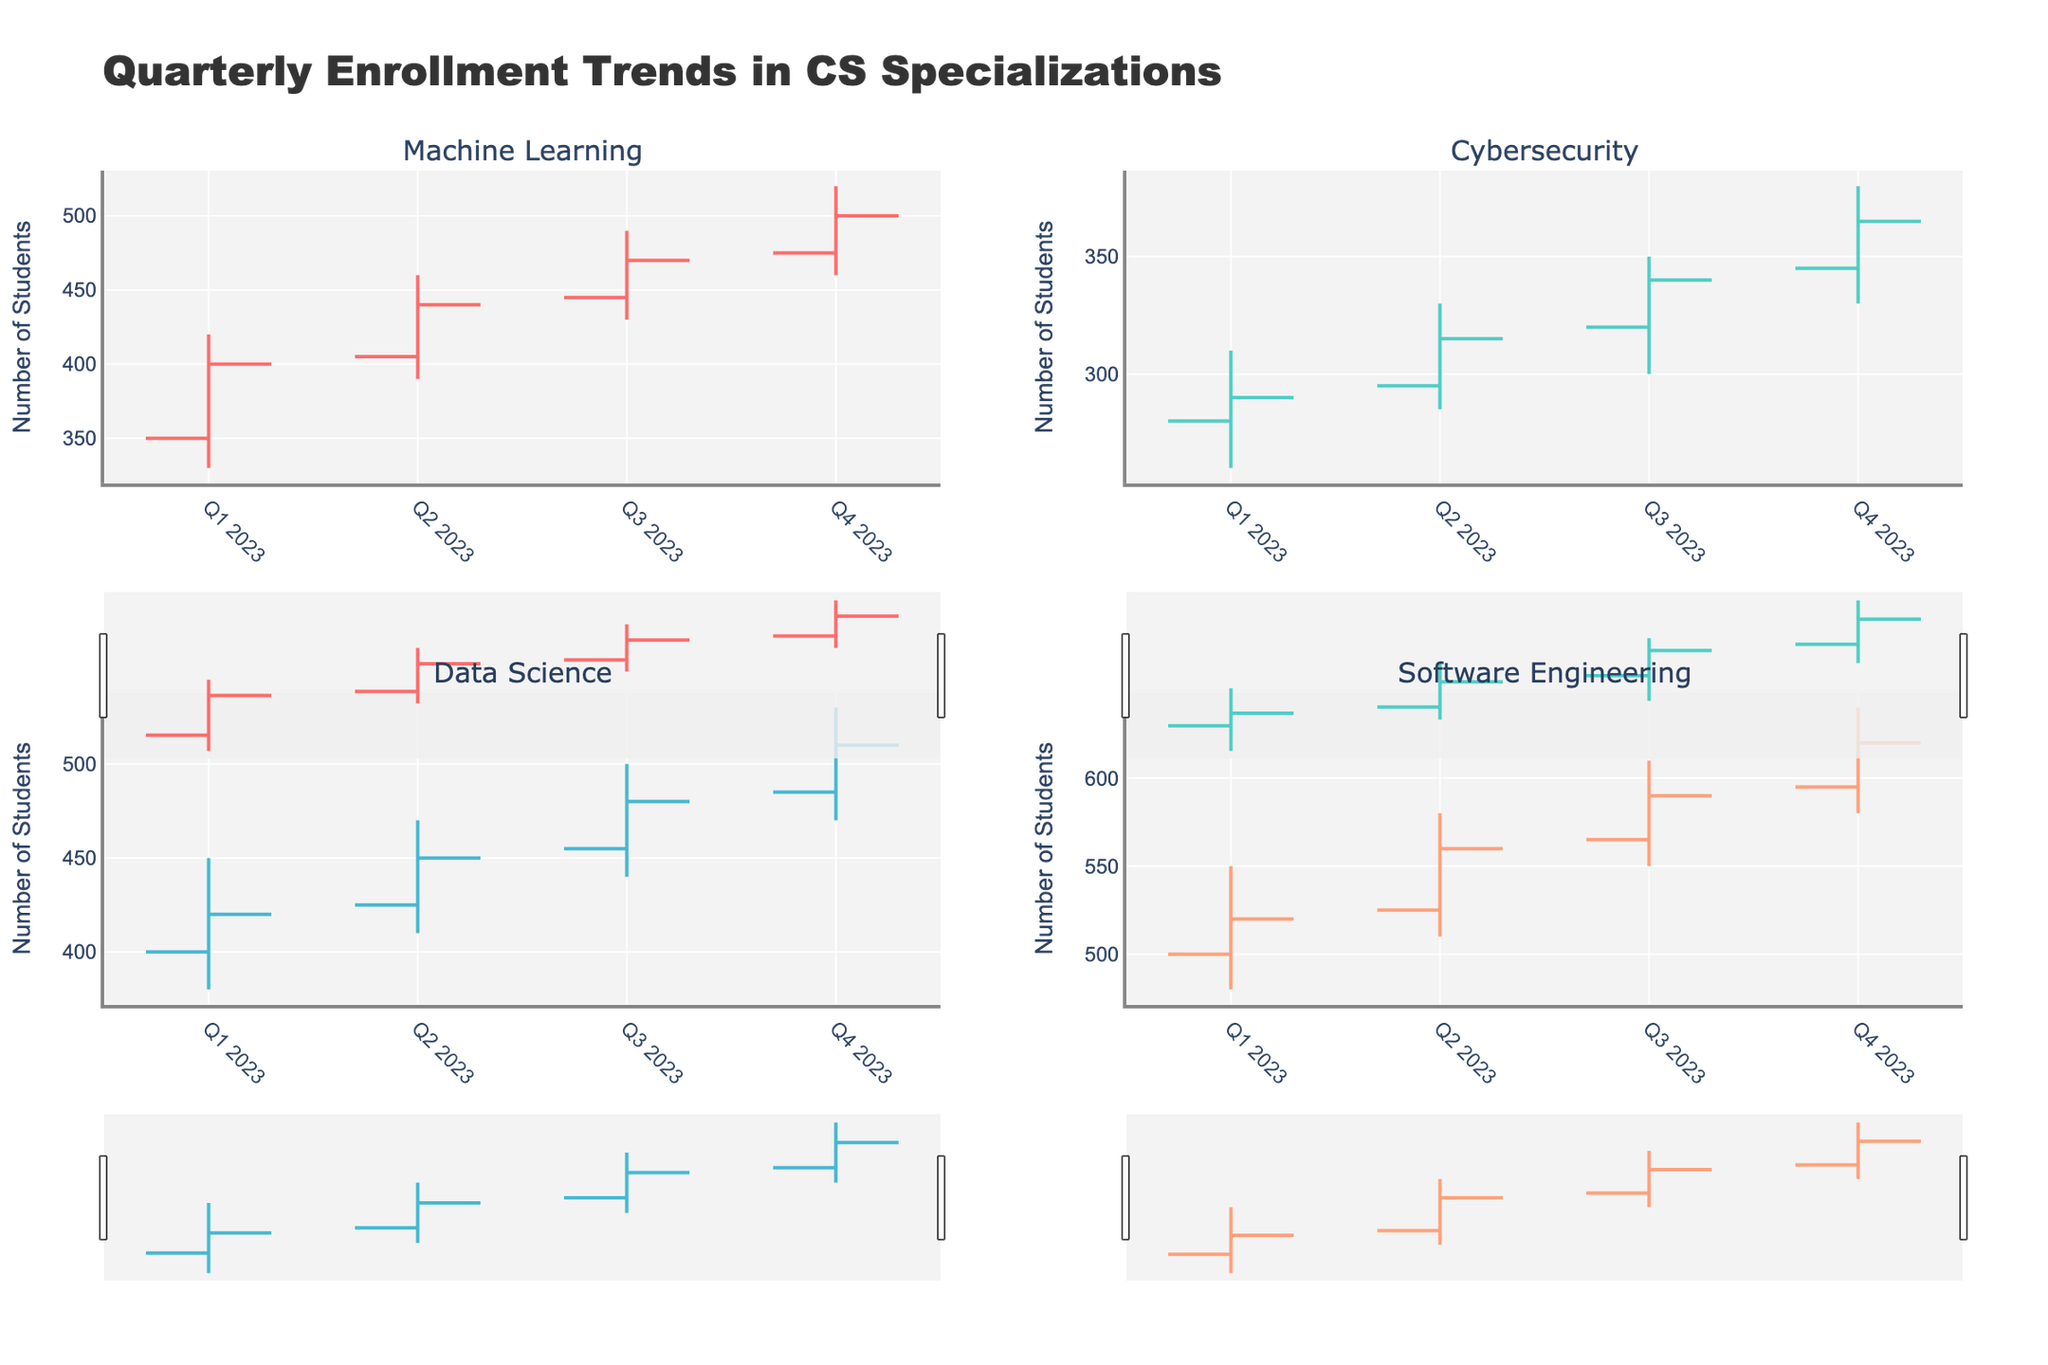Which specialization had the highest enrollment in Q1 2023? We need to look at the 'High' values for Q1 2023 in each specialization. Software Engineering has the highest value of 550.
Answer: Software Engineering In Q2 2023, which specialization showed the highest increase in enrollment from its opening to closing values? We calculate the difference between the 'Close' and 'Open' values for each specialization in Q2 2023. Machine Learning: 440 - 405 = 35, Cybersecurity: 315 - 295 = 20, Data Science: 450 - 425 = 25, Software Engineering: 560 - 525 = 35. Both Machine Learning and Software Engineering show an increase of 35.
Answer: Machine Learning and Software Engineering Between Q1 2023 and Q4 2023, did the enrollment for Machine Learning ever decrease from one quarter to the next? We check the 'Close' values for Machine Learning across the quarters: Q1 2023 to Q2 2023: 400 < 440 (increase); Q2 2023 to Q3 2023: 440 < 470 (increase); Q3 2023 to Q4 2023: 470 < 500 (increase).
Answer: No Which specialization showed the most consistency in their enrollment numbers in 2023? Consistency can be assessed by the range (High - Low) values across quarters. First, calculate this for each specialization: Machine Learning: (90, 70, 60, 60), Cybersecurity: (50, 45, 50, 50), Data Science: (70, 60, 60, 60), Software Engineering: (70, 70, 60, 60). Cybersecurity has the consistent range.
Answer: Cybersecurity How does the Q4 2023 closing enrollment for Data Science compare to its opening enrollment? We look at the 'Close' value for Q4 2023 for Data Science, which is 510, and compare it to the 'Open' value of 485. 510 > 485 meaning it increased.
Answer: Increased What was the lowest enrollment number recorded in any quarter for Cybersecurity in 2023? We identify all the 'Low' values for Cybersecurity throughout 2023: 260, 285, 300, and 330. The lowest value is 260.
Answer: 260 Which specialization had the greatest overall increase in enrollment from the beginning to the end of 2023? We need to compare the 'Open' value for Q1 2023 and the 'Close' value for Q4 2023 of each specialization. Calculate the differences: Machine Learning: 500 - 350 = 150, Cybersecurity: 365 - 280 = 85, Data Science: 510 - 400 = 110, Software Engineering: 620 - 500 = 120. Machine Learning shows the highest increase.
Answer: Machine Learning What was the highest peak enrollment number (High value) recorded across all specializations in any quarter of 2023? We check all the 'High' values across all specializations and quarters: Machine Learning (420, 460, 490, 520), Cybersecurity (310, 330, 350, 380), Data Science (450, 470, 500, 530), Software Engineering (550, 580, 610, 640). The highest value is 640 in Q4 2023 for Software Engineering.
Answer: 640 